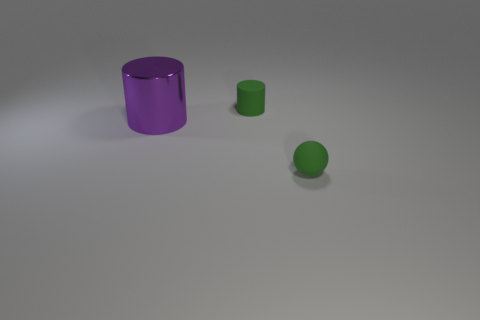Add 3 large shiny things. How many objects exist? 6 Subtract all cylinders. How many objects are left? 1 Add 3 metallic objects. How many metallic objects exist? 4 Subtract 0 gray cylinders. How many objects are left? 3 Subtract all matte things. Subtract all purple shiny cylinders. How many objects are left? 0 Add 3 purple cylinders. How many purple cylinders are left? 4 